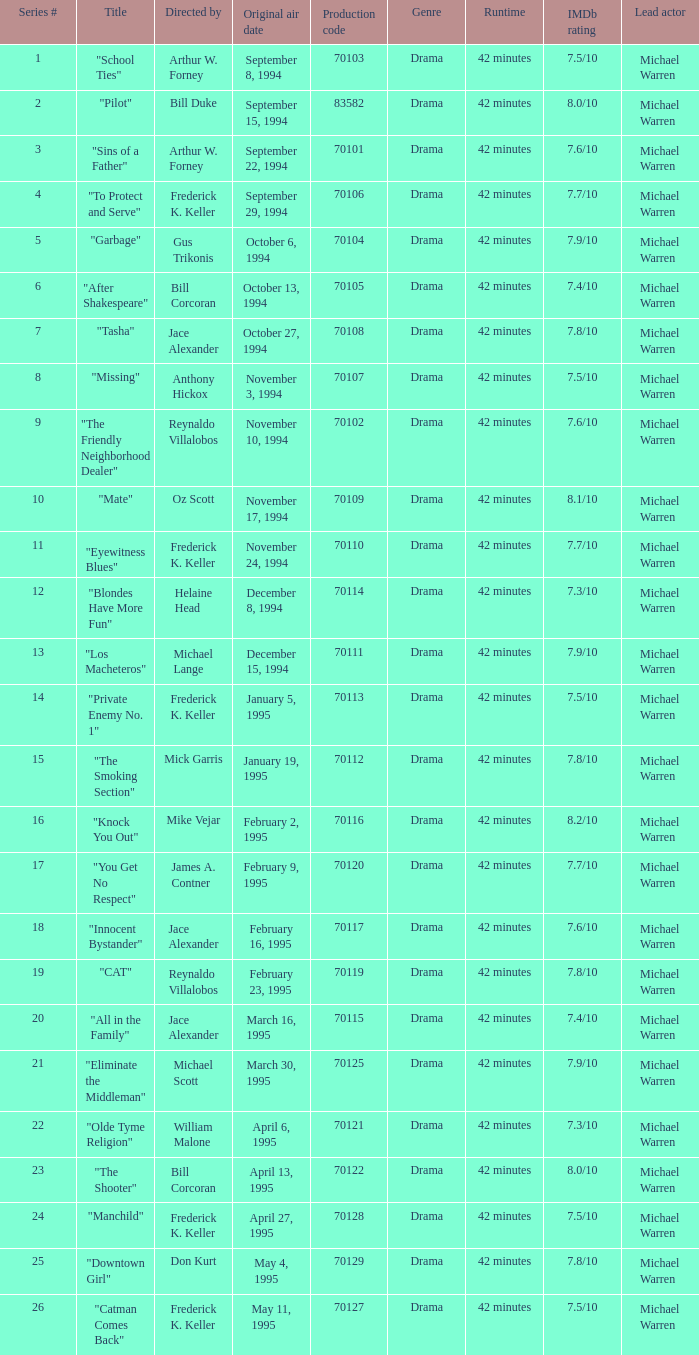For the "Downtown Girl" episode, what was the original air date? May 4, 1995. 